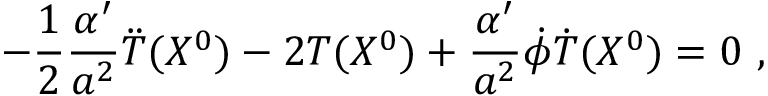Convert formula to latex. <formula><loc_0><loc_0><loc_500><loc_500>- \frac { 1 } { 2 } \frac { \alpha ^ { \prime } } { a ^ { 2 } } \ddot { T } ( X ^ { 0 } ) - 2 T ( X ^ { 0 } ) + \frac { \alpha ^ { \prime } } { a ^ { 2 } } \dot { \phi } \dot { T } ( X ^ { 0 } ) = 0 \ ,</formula> 